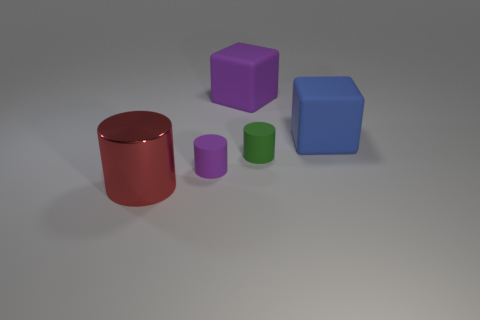There is a purple rubber object that is the same shape as the large red metal object; what size is it?
Your answer should be very brief. Small. What number of things are on the right side of the tiny matte cylinder that is right of the large purple cube?
Offer a terse response. 1. Do the cube to the right of the green matte thing and the large object that is in front of the small purple cylinder have the same material?
Your answer should be compact. No. What number of big blue objects are the same shape as the tiny purple object?
Your response must be concise. 0. What number of other metallic objects are the same color as the metal thing?
Provide a succinct answer. 0. There is a small green rubber thing to the right of the big purple cube; is it the same shape as the matte thing to the right of the green object?
Ensure brevity in your answer.  No. What number of cubes are to the left of the large blue rubber cube that is right of the large thing behind the big blue cube?
Provide a succinct answer. 1. What is the material of the thing that is behind the matte block in front of the purple thing behind the small green matte object?
Provide a short and direct response. Rubber. Is the small cylinder in front of the green object made of the same material as the big blue thing?
Offer a terse response. Yes. What number of matte cylinders are the same size as the blue cube?
Provide a short and direct response. 0. 